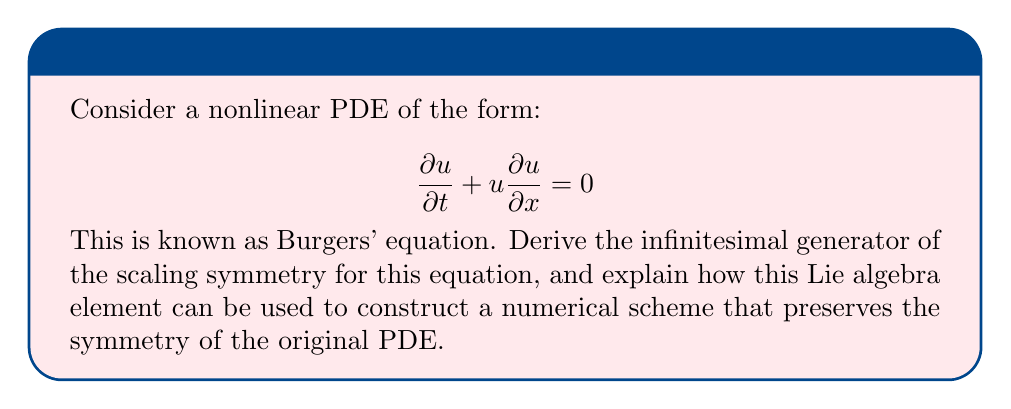Solve this math problem. 1) First, we need to find the scaling symmetry of Burgers' equation. Let's consider the transformation:

   $$(x, t, u) \rightarrow (e^\epsilon x, e^{k\epsilon} t, e^{m\epsilon} u)$$

   where $\epsilon$ is a small parameter and $k, m$ are constants to be determined.

2) For this to be a symmetry, the equation must remain invariant under this transformation. Applying the transformation:

   $$e^{(m-k)\epsilon}\frac{\partial u}{\partial t} + e^{(2m-1)\epsilon}u\frac{\partial u}{\partial x} = 0$$

3) For invariance, we need:

   $$m - k = 2m - 1$$
   
   Solving this, we get $k = m + 1$.

4) The infinitesimal generator of this symmetry is:

   $$X = x\frac{\partial}{\partial x} + (m+1)t\frac{\partial}{\partial t} + mu\frac{\partial}{\partial u}$$

5) This forms a one-dimensional Lie algebra. The commutator of this generator with itself is zero: $[X,X] = 0$.

6) To construct a symmetry-preserving numerical scheme, we can use the Lie-Trotter splitting method. We split the PDE into two parts:

   $$\frac{\partial u}{\partial t} = 0$$ and $$\frac{\partial u}{\partial t} + u\frac{\partial u}{\partial x} = 0$$

7) For the first part, we use a scheme that respects the scaling in $t$ and $u$:

   $$u^{n+1} = \left(\frac{t^{n+1}}{t^n}\right)^{m/(m+1)} u^n$$

8) For the second part, we use a scheme that respects the scaling in $x$ and $u$:

   $$\frac{u_i^{n+1} - u_i^n}{\Delta t} + u_i^n \frac{u_{i+1}^n - u_{i-1}^n}{2\Delta x} = 0$$

9) Combining these two steps gives a symmetry-preserving scheme for the full equation.
Answer: The infinitesimal generator is $X = x\frac{\partial}{\partial x} + (m+1)t\frac{\partial}{\partial t} + mu\frac{\partial}{\partial u}$. Use Lie-Trotter splitting with scaling-respecting schemes for each part. 